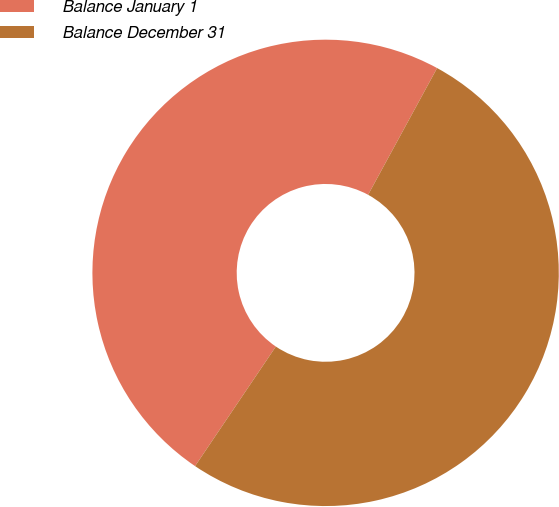Convert chart to OTSL. <chart><loc_0><loc_0><loc_500><loc_500><pie_chart><fcel>Balance January 1<fcel>Balance December 31<nl><fcel>48.48%<fcel>51.52%<nl></chart> 